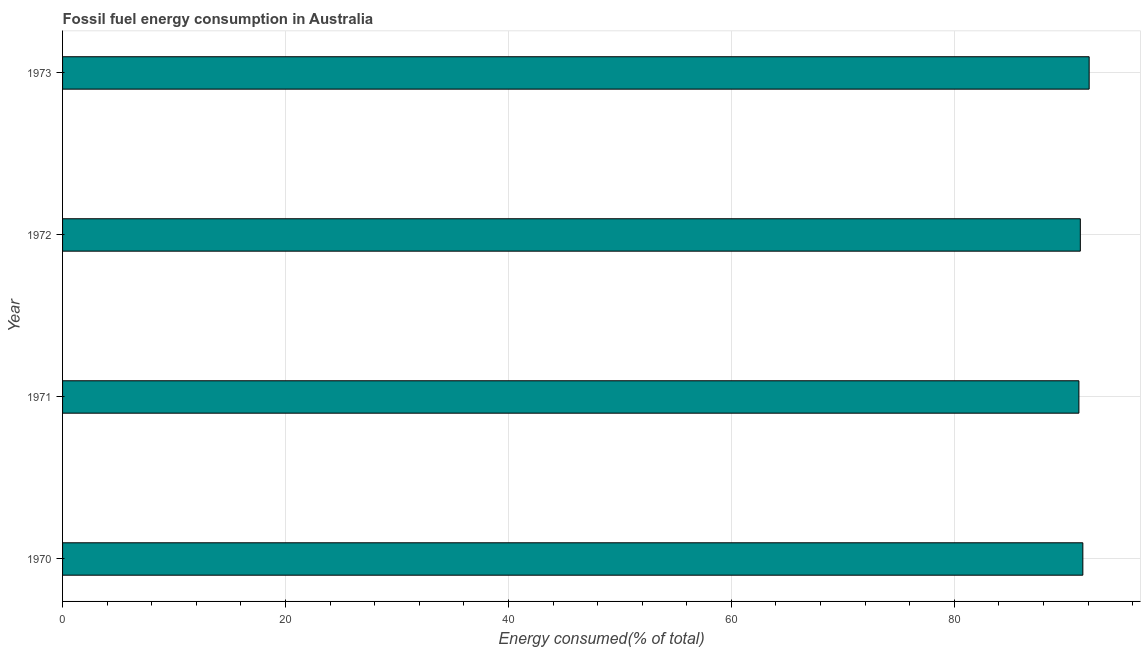Does the graph contain any zero values?
Offer a very short reply. No. Does the graph contain grids?
Your answer should be compact. Yes. What is the title of the graph?
Provide a short and direct response. Fossil fuel energy consumption in Australia. What is the label or title of the X-axis?
Your response must be concise. Energy consumed(% of total). What is the fossil fuel energy consumption in 1970?
Give a very brief answer. 91.53. Across all years, what is the maximum fossil fuel energy consumption?
Your response must be concise. 92.1. Across all years, what is the minimum fossil fuel energy consumption?
Provide a short and direct response. 91.18. In which year was the fossil fuel energy consumption minimum?
Keep it short and to the point. 1971. What is the sum of the fossil fuel energy consumption?
Your response must be concise. 366.11. What is the difference between the fossil fuel energy consumption in 1972 and 1973?
Your answer should be very brief. -0.79. What is the average fossil fuel energy consumption per year?
Your answer should be compact. 91.53. What is the median fossil fuel energy consumption?
Make the answer very short. 91.42. Is the difference between the fossil fuel energy consumption in 1970 and 1972 greater than the difference between any two years?
Your response must be concise. No. What is the difference between the highest and the second highest fossil fuel energy consumption?
Provide a succinct answer. 0.57. How many bars are there?
Make the answer very short. 4. How many years are there in the graph?
Give a very brief answer. 4. What is the difference between two consecutive major ticks on the X-axis?
Your response must be concise. 20. Are the values on the major ticks of X-axis written in scientific E-notation?
Your answer should be very brief. No. What is the Energy consumed(% of total) in 1970?
Offer a very short reply. 91.53. What is the Energy consumed(% of total) of 1971?
Provide a short and direct response. 91.18. What is the Energy consumed(% of total) of 1972?
Your answer should be compact. 91.31. What is the Energy consumed(% of total) of 1973?
Provide a short and direct response. 92.1. What is the difference between the Energy consumed(% of total) in 1970 and 1971?
Give a very brief answer. 0.35. What is the difference between the Energy consumed(% of total) in 1970 and 1972?
Offer a terse response. 0.23. What is the difference between the Energy consumed(% of total) in 1970 and 1973?
Your answer should be compact. -0.57. What is the difference between the Energy consumed(% of total) in 1971 and 1972?
Provide a succinct answer. -0.13. What is the difference between the Energy consumed(% of total) in 1971 and 1973?
Keep it short and to the point. -0.92. What is the difference between the Energy consumed(% of total) in 1972 and 1973?
Give a very brief answer. -0.79. What is the ratio of the Energy consumed(% of total) in 1970 to that in 1973?
Give a very brief answer. 0.99. What is the ratio of the Energy consumed(% of total) in 1971 to that in 1973?
Give a very brief answer. 0.99. What is the ratio of the Energy consumed(% of total) in 1972 to that in 1973?
Offer a very short reply. 0.99. 